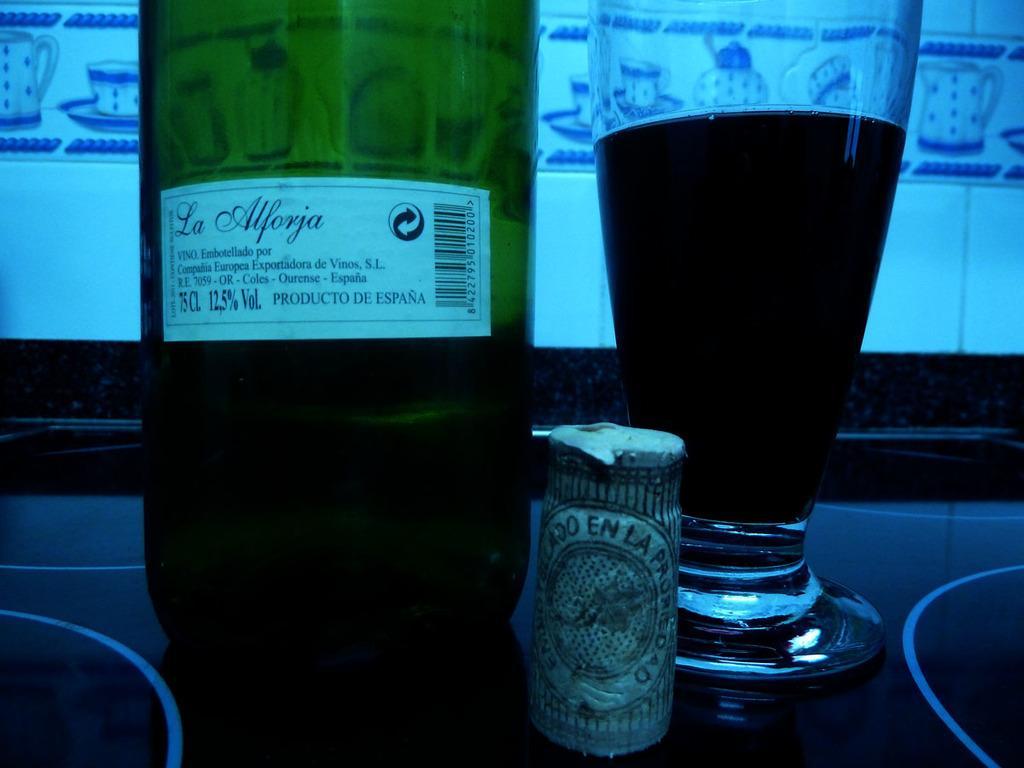Please provide a concise description of this image. there is a bottle and a glass in which a liquid is present in it. 